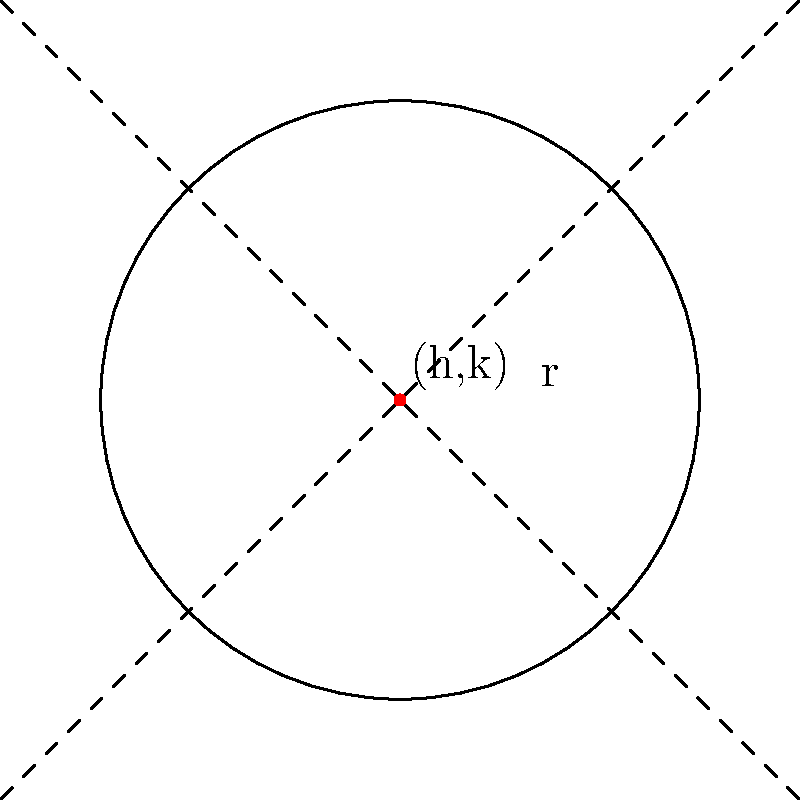During your home renovation, you decide to install a circular window. The general equation of the circle representing the window is $x^2 + y^2 - 6x + 4y + 13 = 0$. Find the center and radius of this circular window. To find the center and radius of the circle, we need to convert the general equation to standard form. Let's follow these steps:

1) The general form of a circle equation is:
   $x^2 + y^2 + Ax + By + C = 0$

2) In our case, we have:
   $x^2 + y^2 - 6x + 4y + 13 = 0$

3) To convert to standard form $(x-h)^2 + (y-k)^2 = r^2$, we need to complete the square for both x and y terms:

   For x terms:
   $x^2 - 6x = (x^2 - 6x + 9) - 9 = (x-3)^2 - 9$

   For y terms:
   $y^2 + 4y = (y^2 + 4y + 4) - 4 = (y+2)^2 - 4$

4) Substituting back into the equation:
   $(x-3)^2 - 9 + (y+2)^2 - 4 + 13 = 0$
   $(x-3)^2 + (y+2)^2 = 0$

5) This is now in standard form $(x-h)^2 + (y-k)^2 = r^2$, where:
   $h = 3$
   $k = -2$
   $r^2 = 0$

6) Therefore, the center of the circle is $(3,-2)$
   The radius is $r = \sqrt{0} = 0$

However, a circle with radius 0 is just a point. This means our window has collapsed to a single point, which is not physically possible. In a real-world scenario, this would indicate an error in measurement or calculation.
Answer: Center: (3,-2), Radius: 0 (point) 